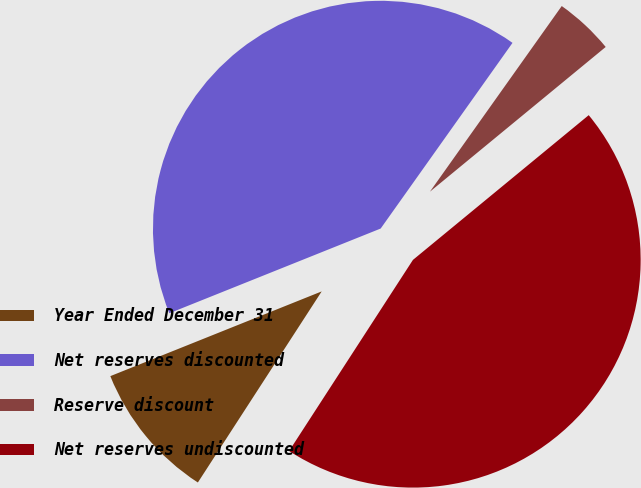Convert chart to OTSL. <chart><loc_0><loc_0><loc_500><loc_500><pie_chart><fcel>Year Ended December 31<fcel>Net reserves discounted<fcel>Reserve discount<fcel>Net reserves undiscounted<nl><fcel>9.78%<fcel>40.89%<fcel>4.21%<fcel>45.11%<nl></chart> 